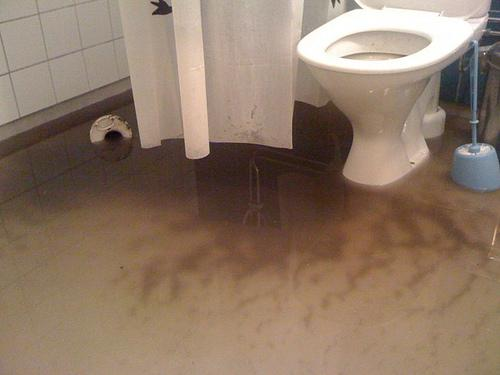Question: how is the photo?
Choices:
A. Clear.
B. Fuzzy.
C. Blurry.
D. Dark.
Answer with the letter. Answer: A Question: what type of scene is this?
Choices:
A. Indoor.
B. Outdoor.
C. Underwater.
D. In the air.
Answer with the letter. Answer: A Question: what is on the floor?
Choices:
A. Ice.
B. Sand.
C. Water.
D. Dirt.
Answer with the letter. Answer: C Question: who is there?
Choices:
A. No one.
B. A man.
C. A family.
D. A woman.
Answer with the letter. Answer: A 